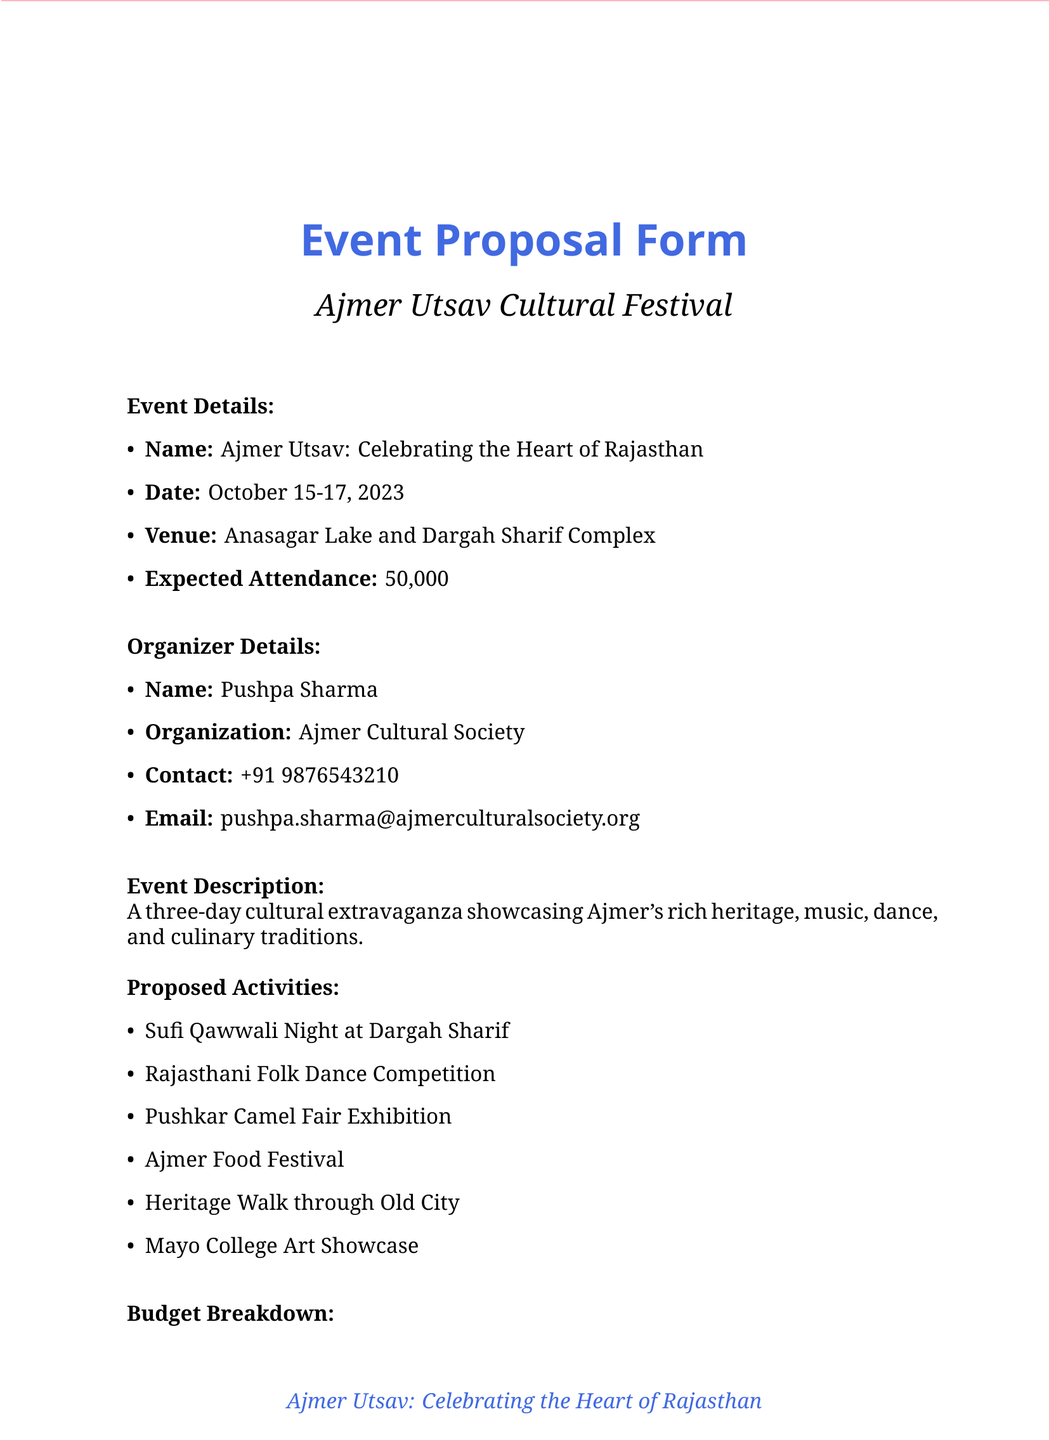What is the event date? The event date is specified in the document for Ajmer Utsav, which occurs over a three-day period.
Answer: October 15-17, 2023 Who is the organizer of the event? The document clearly identifies the organizer's name and organization.
Answer: Pushpa Sharma What is the total budget for the event? The total budget is listed in the budget breakdown section of the document.
Answer: 750000 How many first aid stations will be present? The number of first aid stations is mentioned under the medical and safety logistics requirements.
Answer: 3 What activity involves a traditional drink? This activity is related to food and beverages and holds cultural significance in Ajmer.
Answer: Ajmer Food Festival Where will the Sufi Qawwali Night take place? The specific location for this activity is noted in the proposed activities section.
Answer: Dargah Sharif What type of seating arrangements are planned for the event? The document describes both chair and traditional seating options in the logistics requirements.
Answer: Traditional floor seating arrangements Which organization is the title sponsor? Sponsorship opportunities are provided in the document, stating the primary sponsor for the event.
Answer: Rajasthan Tourism Development Corporation How many artists are involved in the event? The document lists local artists involved, allowing us to count the total number mentioned.
Answer: 4 